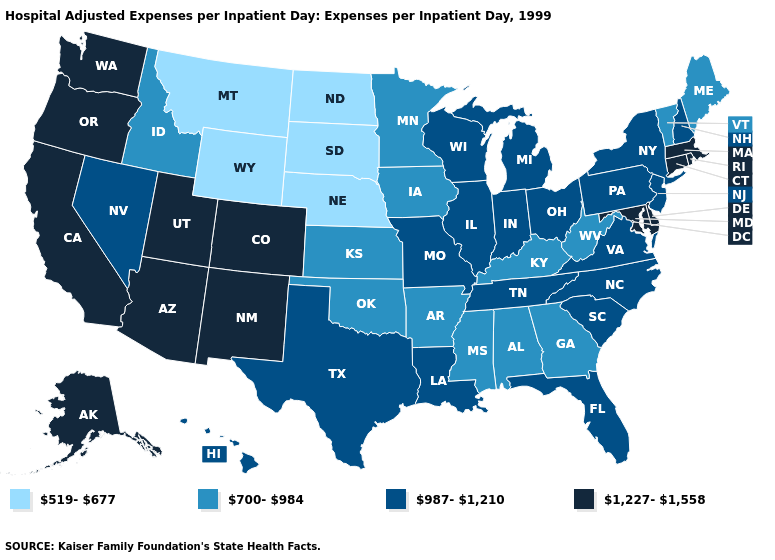Does Florida have the highest value in the USA?
Keep it brief. No. What is the highest value in the USA?
Give a very brief answer. 1,227-1,558. Which states have the lowest value in the USA?
Give a very brief answer. Montana, Nebraska, North Dakota, South Dakota, Wyoming. Does the map have missing data?
Keep it brief. No. Name the states that have a value in the range 519-677?
Give a very brief answer. Montana, Nebraska, North Dakota, South Dakota, Wyoming. What is the value of Indiana?
Give a very brief answer. 987-1,210. Name the states that have a value in the range 1,227-1,558?
Write a very short answer. Alaska, Arizona, California, Colorado, Connecticut, Delaware, Maryland, Massachusetts, New Mexico, Oregon, Rhode Island, Utah, Washington. Name the states that have a value in the range 700-984?
Give a very brief answer. Alabama, Arkansas, Georgia, Idaho, Iowa, Kansas, Kentucky, Maine, Minnesota, Mississippi, Oklahoma, Vermont, West Virginia. Which states have the highest value in the USA?
Write a very short answer. Alaska, Arizona, California, Colorado, Connecticut, Delaware, Maryland, Massachusetts, New Mexico, Oregon, Rhode Island, Utah, Washington. Name the states that have a value in the range 519-677?
Give a very brief answer. Montana, Nebraska, North Dakota, South Dakota, Wyoming. Name the states that have a value in the range 1,227-1,558?
Keep it brief. Alaska, Arizona, California, Colorado, Connecticut, Delaware, Maryland, Massachusetts, New Mexico, Oregon, Rhode Island, Utah, Washington. Name the states that have a value in the range 1,227-1,558?
Quick response, please. Alaska, Arizona, California, Colorado, Connecticut, Delaware, Maryland, Massachusetts, New Mexico, Oregon, Rhode Island, Utah, Washington. Name the states that have a value in the range 700-984?
Concise answer only. Alabama, Arkansas, Georgia, Idaho, Iowa, Kansas, Kentucky, Maine, Minnesota, Mississippi, Oklahoma, Vermont, West Virginia. What is the lowest value in states that border New Hampshire?
Keep it brief. 700-984. What is the value of Georgia?
Give a very brief answer. 700-984. 